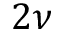<formula> <loc_0><loc_0><loc_500><loc_500>2 \nu</formula> 